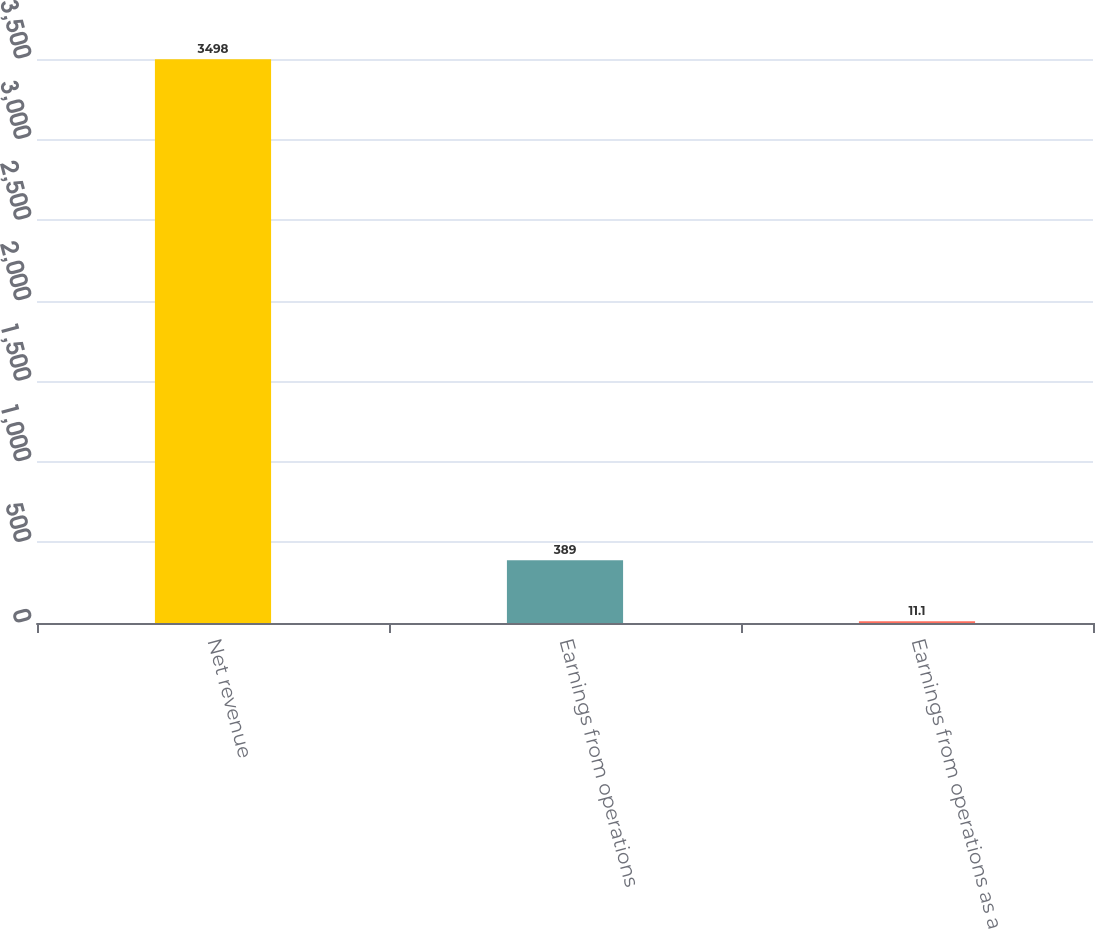Convert chart. <chart><loc_0><loc_0><loc_500><loc_500><bar_chart><fcel>Net revenue<fcel>Earnings from operations<fcel>Earnings from operations as a<nl><fcel>3498<fcel>389<fcel>11.1<nl></chart> 